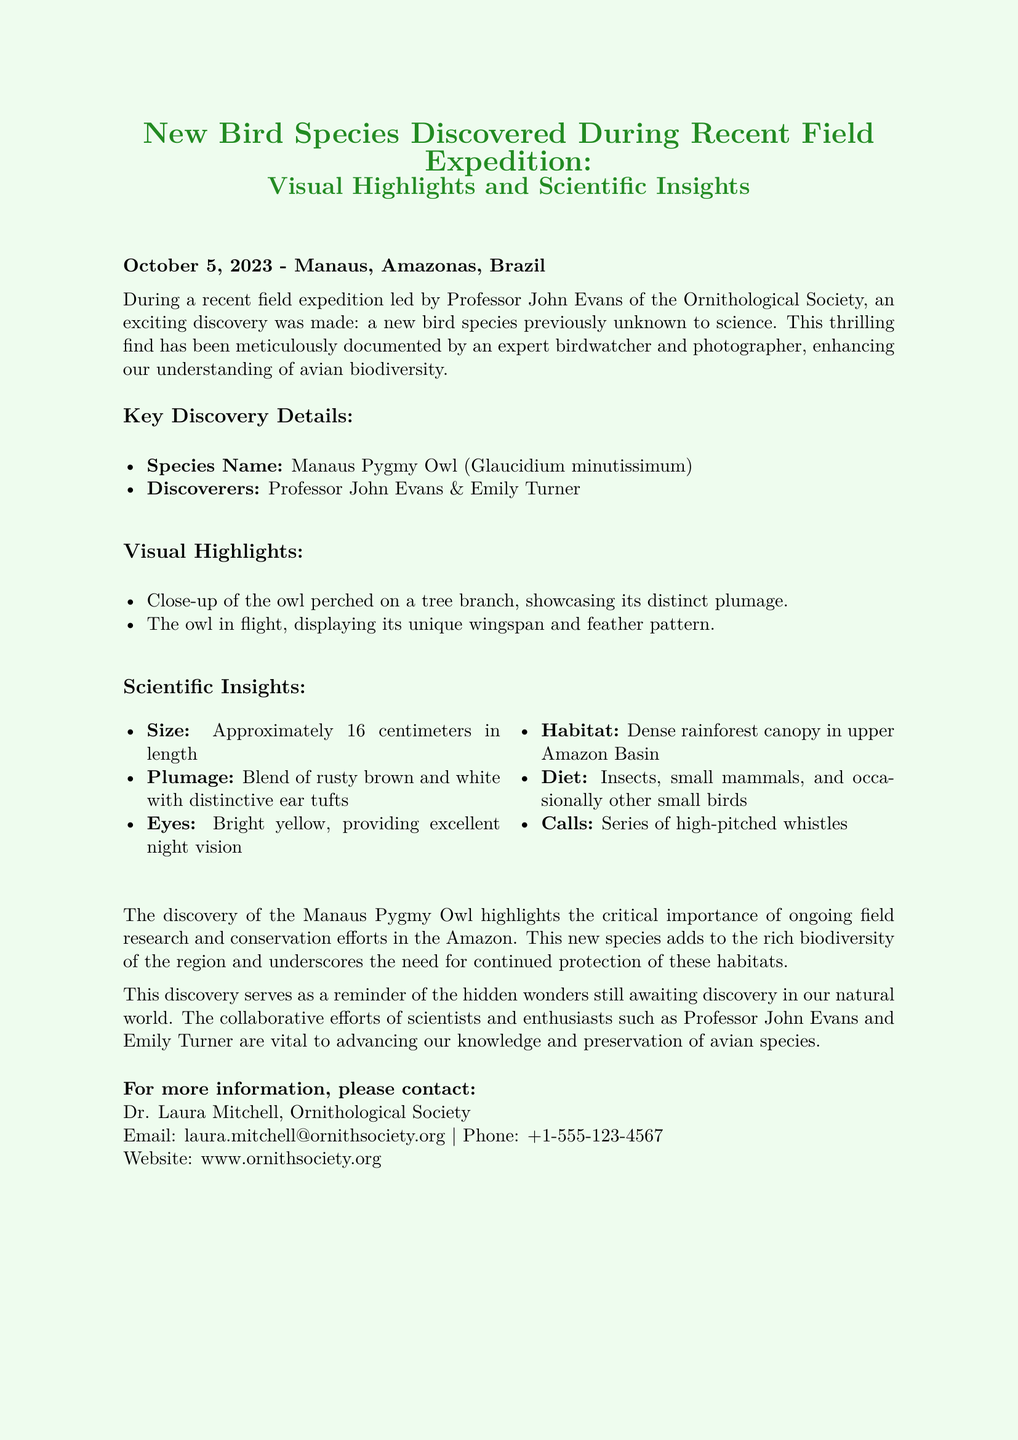What is the name of the new bird species? The name of the new bird species is listed in the document under "Species Name."
Answer: Manaus Pygmy Owl Who were the discoverers of the new species? The discoverers are mentioned near the beginning of the document, listing both individuals.
Answer: Professor John Evans & Emily Turner What is the length of the Manaus Pygmy Owl? The document specifies the size measurement of the owl.
Answer: Approximately 16 centimeters What is a distinguishing feature of the owl's plumage? The plumage details are provided under "Scientific Insights."
Answer: Blend of rusty brown and white with distinctive ear tufts What type of habitat does the Manaus Pygmy Owl prefer? The habitat is specified in the "Scientific Insights" section.
Answer: Dense rainforest canopy in upper Amazon Basin What are the calls of the Manaus Pygmy Owl described as? The description of the calls can be found in the section about scientific insights.
Answer: Series of high-pitched whistles On what date was the discovery announced? The date is mentioned at the beginning of the document.
Answer: October 5, 2023 What is the importance of ongoing field research highlighted in the document? The document discusses the implications of the discovery and stresses the importance of research and conservation.
Answer: Critical importance of ongoing field research and conservation efforts in the Amazon What organization is Dr. Laura Mitchell affiliated with? Dr. Laura Mitchell's affiliation is stated at the end of the document.
Answer: Ornithological Society 